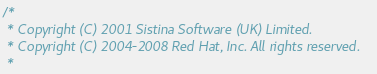Convert code to text. <code><loc_0><loc_0><loc_500><loc_500><_C_>/*
 * Copyright (C) 2001 Sistina Software (UK) Limited.
 * Copyright (C) 2004-2008 Red Hat, Inc. All rights reserved.
 *</code> 